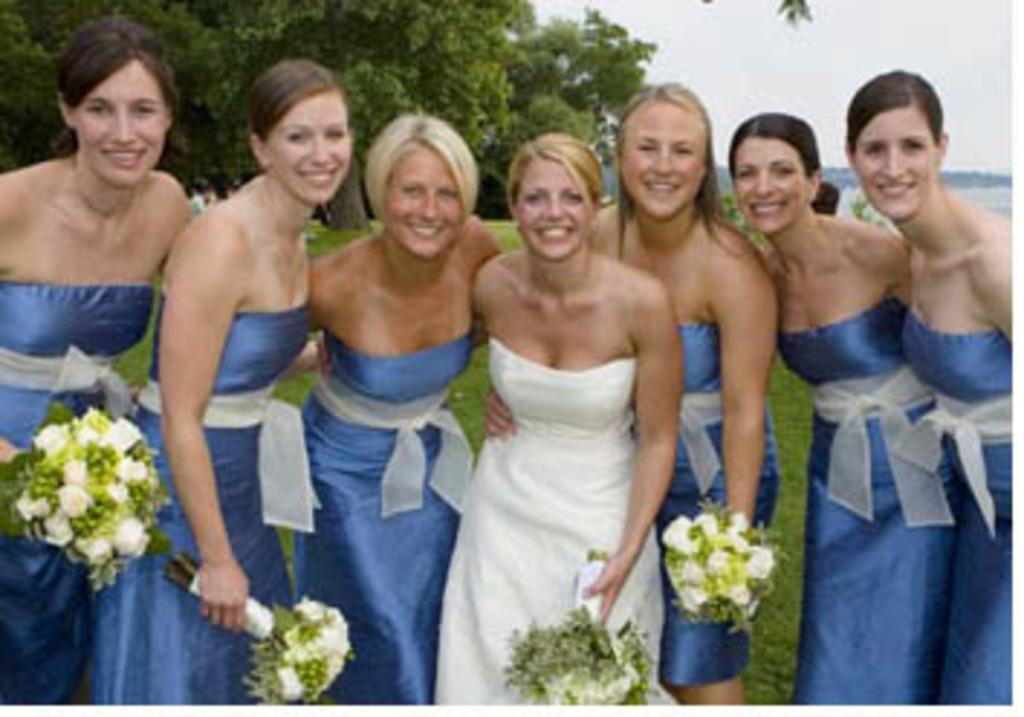What is the main subject of the image? The main subject of the image is a group of women. What are the women doing in the image? The women are smiling and holding bouquets. What can be seen in the background of the image? There is grass, sky, and trees visible in the background of the image. What type of stick can be seen in the image? There is no stick present in the image. What is the rate of the women's laughter in the image? The image does not provide information about the rate of the women's laughter. 